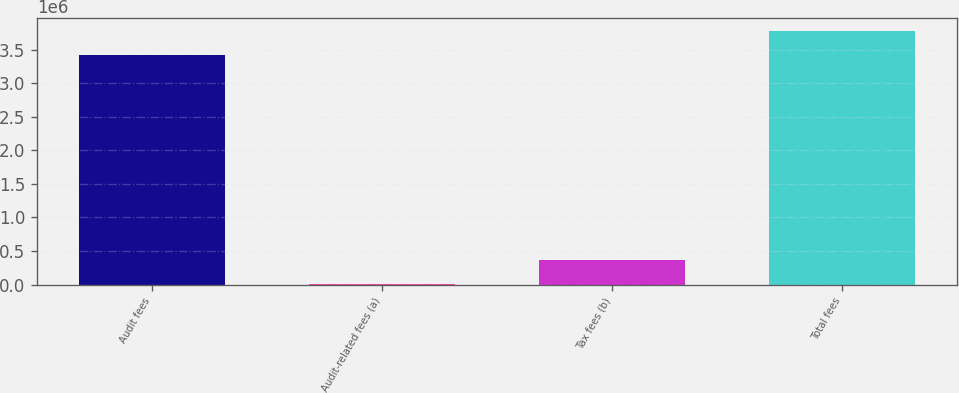<chart> <loc_0><loc_0><loc_500><loc_500><bar_chart><fcel>Audit fees<fcel>Audit-related fees (a)<fcel>Tax fees (b)<fcel>Total fees<nl><fcel>3.42378e+06<fcel>8215<fcel>368388<fcel>3.78395e+06<nl></chart> 